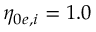Convert formula to latex. <formula><loc_0><loc_0><loc_500><loc_500>\eta _ { 0 e , i } = 1 . 0</formula> 